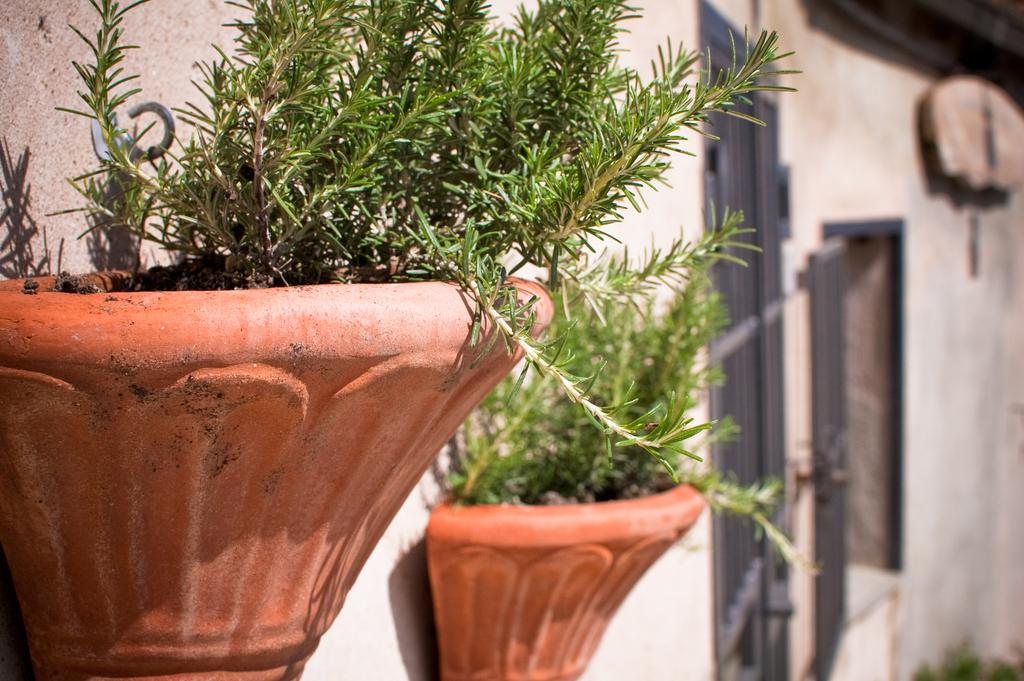What type of living organisms can be seen in the image? Plants can be seen in the image. What is visible in the background of the image? There is a wall visible in the background of the image. What type of holiday is being celebrated in the image? There is no indication in the image that a holiday is being celebrated. How quiet is the environment in the image? The image does not provide any information about the noise level in the environment. 